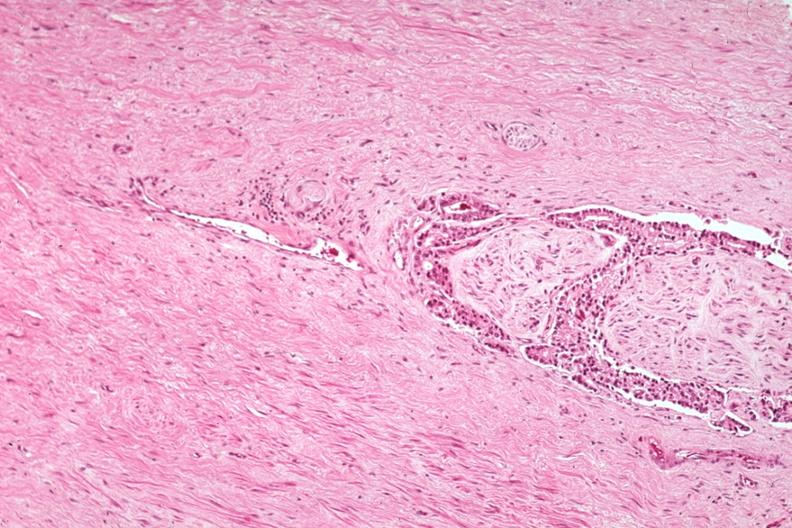what is present?
Answer the question using a single word or phrase. Adenocarcinoma 